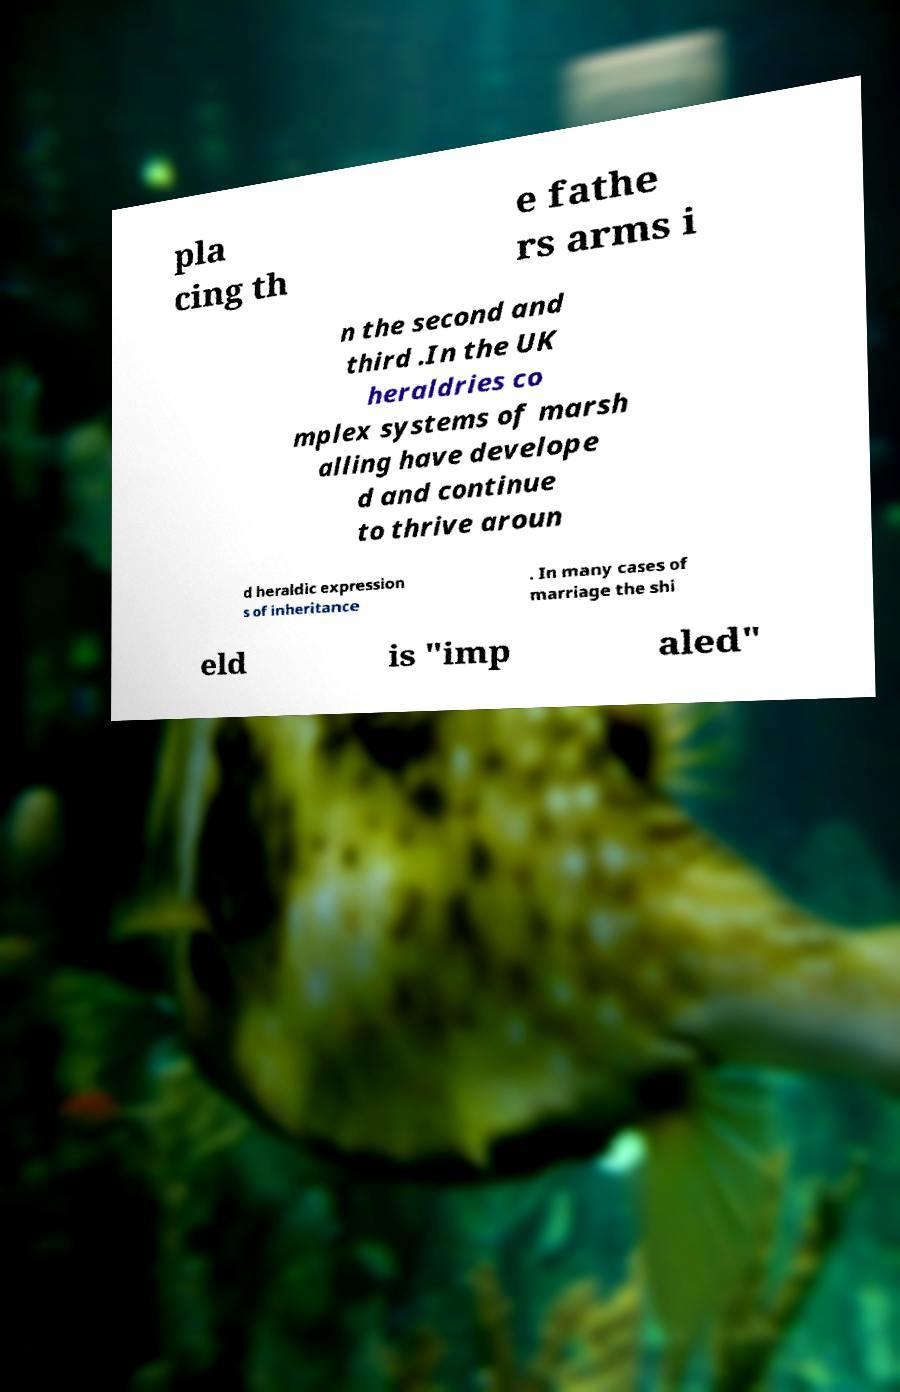Could you extract and type out the text from this image? pla cing th e fathe rs arms i n the second and third .In the UK heraldries co mplex systems of marsh alling have develope d and continue to thrive aroun d heraldic expression s of inheritance . In many cases of marriage the shi eld is "imp aled" 